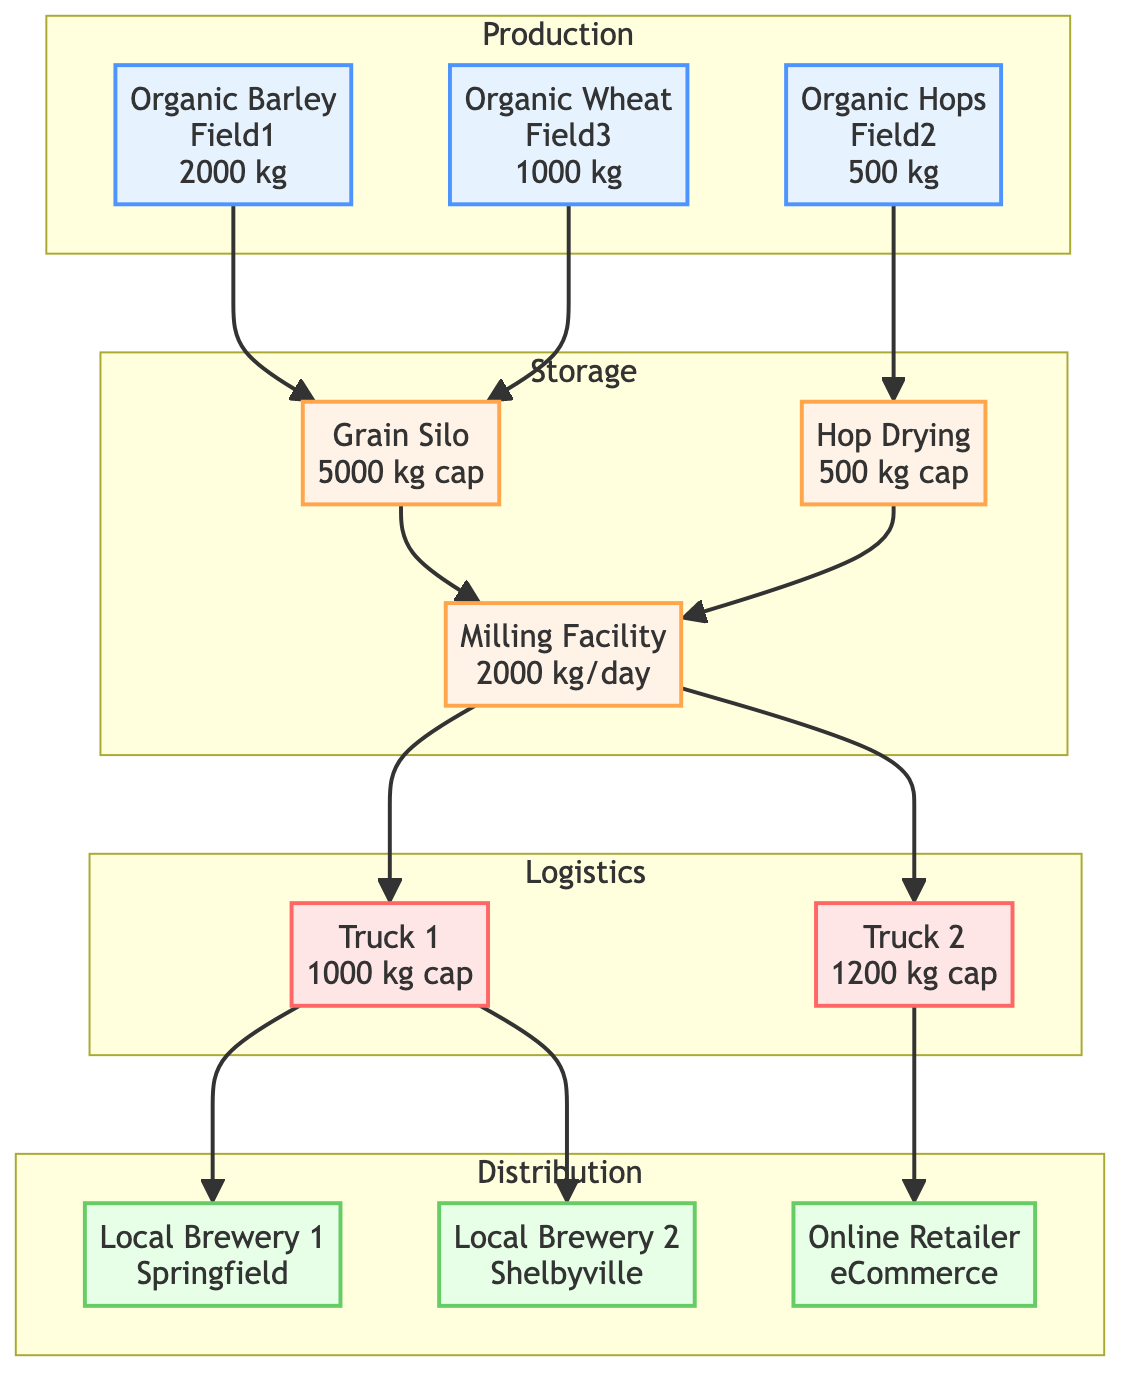What is the output of the Organic Barley field? The Organic Barley field in the production section specifies an output of 2000 kg.
Answer: 2000 kg What is the weekly requirement of Local Brewery 2 for hops? Local Brewery 2 has a weekly requirement of 30 kg of hops as indicated in the distribution section.
Answer: 30 kg What is the capacity of the Hop Drying Facility? The Hop Drying Facility has a capacity of 500 kg, which is noted in the storage section.
Answer: 500 kg Which truck has a capacity of 1200 kg? Truck 2, highlighted in the logistics section, has a capacity of 1200 kg.
Answer: Truck 2 How many nodes are in the distribution section? The distribution section contains three nodes: Local Brewery 1, Local Brewery 2, and Online Retailer. Therefore, the total is 3 nodes.
Answer: 3 Which facility processes both the grain and hops? The Milling Facility processes both grain and hops, as it receives inputs from the Grain Storage Silo and Hop Drying Facility according to the flow in the diagram.
Answer: Milling Facility What is the current stock in the Grain Storage Silo? The current stock in the Grain Storage Silo is 1500 kg, stated in the storage section.
Answer: 1500 kg What routes does Truck 1 operate? Truck 1 operates on two routes: Central Farm Store to Springfield and Central Farm Store to Shelbyville, indicated in the logistics section.
Answer: Central Farm Store to Springfield, Central Farm Store to Shelbyville Which crop is planted in Field 2? Field 2 is designated for Organic Hops as shown in the production section.
Answer: Organic Hops 